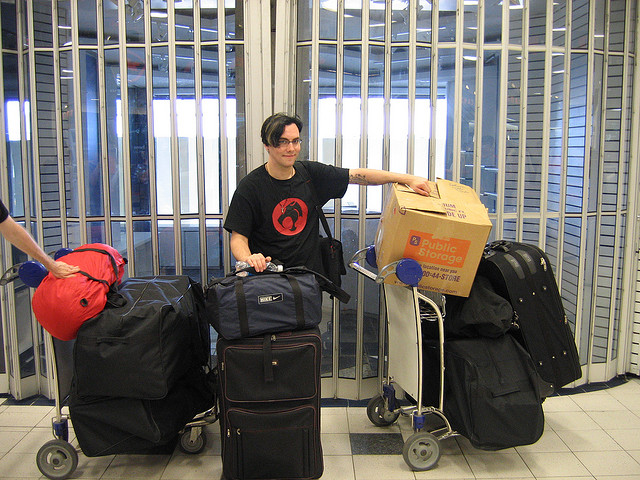Identify and read out the text in this image. Public STORGAE 00-44-STORE 